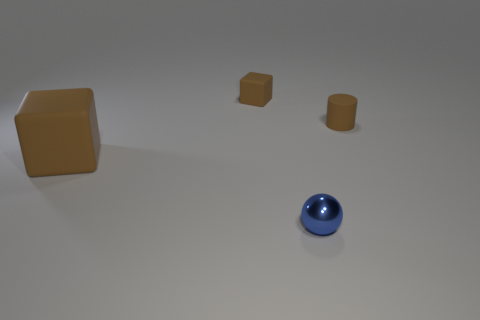There is another block that is the same color as the tiny matte block; what size is it?
Offer a terse response. Large. Is there any other thing that has the same material as the blue thing?
Offer a terse response. No. Is there a brown matte cube behind the brown cube in front of the brown object that is on the right side of the small brown block?
Provide a succinct answer. Yes. What is the small thing in front of the cylinder made of?
Offer a very short reply. Metal. How many large things are either green matte objects or brown cylinders?
Your answer should be very brief. 0. There is a brown matte thing behind the matte cylinder; is its size the same as the tiny shiny sphere?
Offer a terse response. Yes. What number of other things are there of the same color as the tiny cylinder?
Your answer should be very brief. 2. What material is the small cube?
Keep it short and to the point. Rubber. There is a object that is in front of the tiny brown matte cylinder and on the right side of the tiny cube; what is its material?
Give a very brief answer. Metal. What number of objects are either brown blocks to the right of the big rubber object or brown matte blocks?
Provide a short and direct response. 2. 